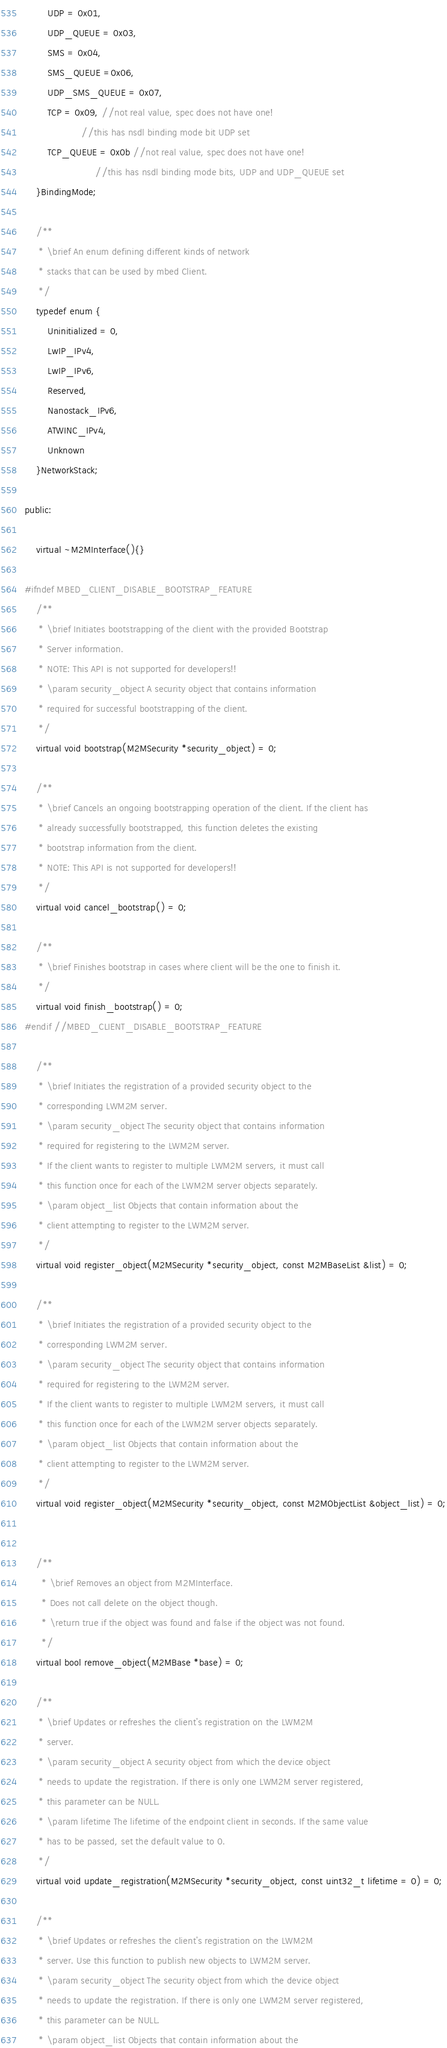<code> <loc_0><loc_0><loc_500><loc_500><_C_>        UDP = 0x01,
        UDP_QUEUE = 0x03,
        SMS = 0x04,
        SMS_QUEUE =0x06,
        UDP_SMS_QUEUE = 0x07,
        TCP = 0x09, //not real value, spec does not have one!
                    //this has nsdl binding mode bit UDP set
        TCP_QUEUE = 0x0b //not real value, spec does not have one!
                         //this has nsdl binding mode bits, UDP and UDP_QUEUE set
    }BindingMode;

    /**
     * \brief An enum defining different kinds of network
     * stacks that can be used by mbed Client.
     */
    typedef enum {
        Uninitialized = 0,
        LwIP_IPv4,
        LwIP_IPv6,
        Reserved,
        Nanostack_IPv6,
        ATWINC_IPv4,
        Unknown
    }NetworkStack;

public:

    virtual ~M2MInterface(){}

#ifndef MBED_CLIENT_DISABLE_BOOTSTRAP_FEATURE
    /**
     * \brief Initiates bootstrapping of the client with the provided Bootstrap
     * Server information.
     * NOTE: This API is not supported for developers!!
     * \param security_object A security object that contains information
     * required for successful bootstrapping of the client.
     */
    virtual void bootstrap(M2MSecurity *security_object) = 0;

    /**
     * \brief Cancels an ongoing bootstrapping operation of the client. If the client has
     * already successfully bootstrapped, this function deletes the existing
     * bootstrap information from the client.
     * NOTE: This API is not supported for developers!!
     */
    virtual void cancel_bootstrap() = 0;

    /**
     * \brief Finishes bootstrap in cases where client will be the one to finish it.
     */
    virtual void finish_bootstrap() = 0;
#endif //MBED_CLIENT_DISABLE_BOOTSTRAP_FEATURE

    /**
     * \brief Initiates the registration of a provided security object to the
     * corresponding LWM2M server.
     * \param security_object The security object that contains information
     * required for registering to the LWM2M server.
     * If the client wants to register to multiple LWM2M servers, it must call
     * this function once for each of the LWM2M server objects separately.
     * \param object_list Objects that contain information about the
     * client attempting to register to the LWM2M server.
     */
    virtual void register_object(M2MSecurity *security_object, const M2MBaseList &list) = 0;

    /**
     * \brief Initiates the registration of a provided security object to the
     * corresponding LWM2M server.
     * \param security_object The security object that contains information
     * required for registering to the LWM2M server.
     * If the client wants to register to multiple LWM2M servers, it must call
     * this function once for each of the LWM2M server objects separately.
     * \param object_list Objects that contain information about the
     * client attempting to register to the LWM2M server.
     */
    virtual void register_object(M2MSecurity *security_object, const M2MObjectList &object_list) = 0;


    /**
      * \brief Removes an object from M2MInterface.
      * Does not call delete on the object though.
      * \return true if the object was found and false if the object was not found.
      */
    virtual bool remove_object(M2MBase *base) = 0;

    /**
     * \brief Updates or refreshes the client's registration on the LWM2M
     * server.
     * \param security_object A security object from which the device object
     * needs to update the registration. If there is only one LWM2M server registered,
     * this parameter can be NULL.
     * \param lifetime The lifetime of the endpoint client in seconds. If the same value
     * has to be passed, set the default value to 0.
     */
    virtual void update_registration(M2MSecurity *security_object, const uint32_t lifetime = 0) = 0;

    /**
     * \brief Updates or refreshes the client's registration on the LWM2M
     * server. Use this function to publish new objects to LWM2M server.
     * \param security_object The security object from which the device object
     * needs to update the registration. If there is only one LWM2M server registered,
     * this parameter can be NULL.
     * \param object_list Objects that contain information about the</code> 